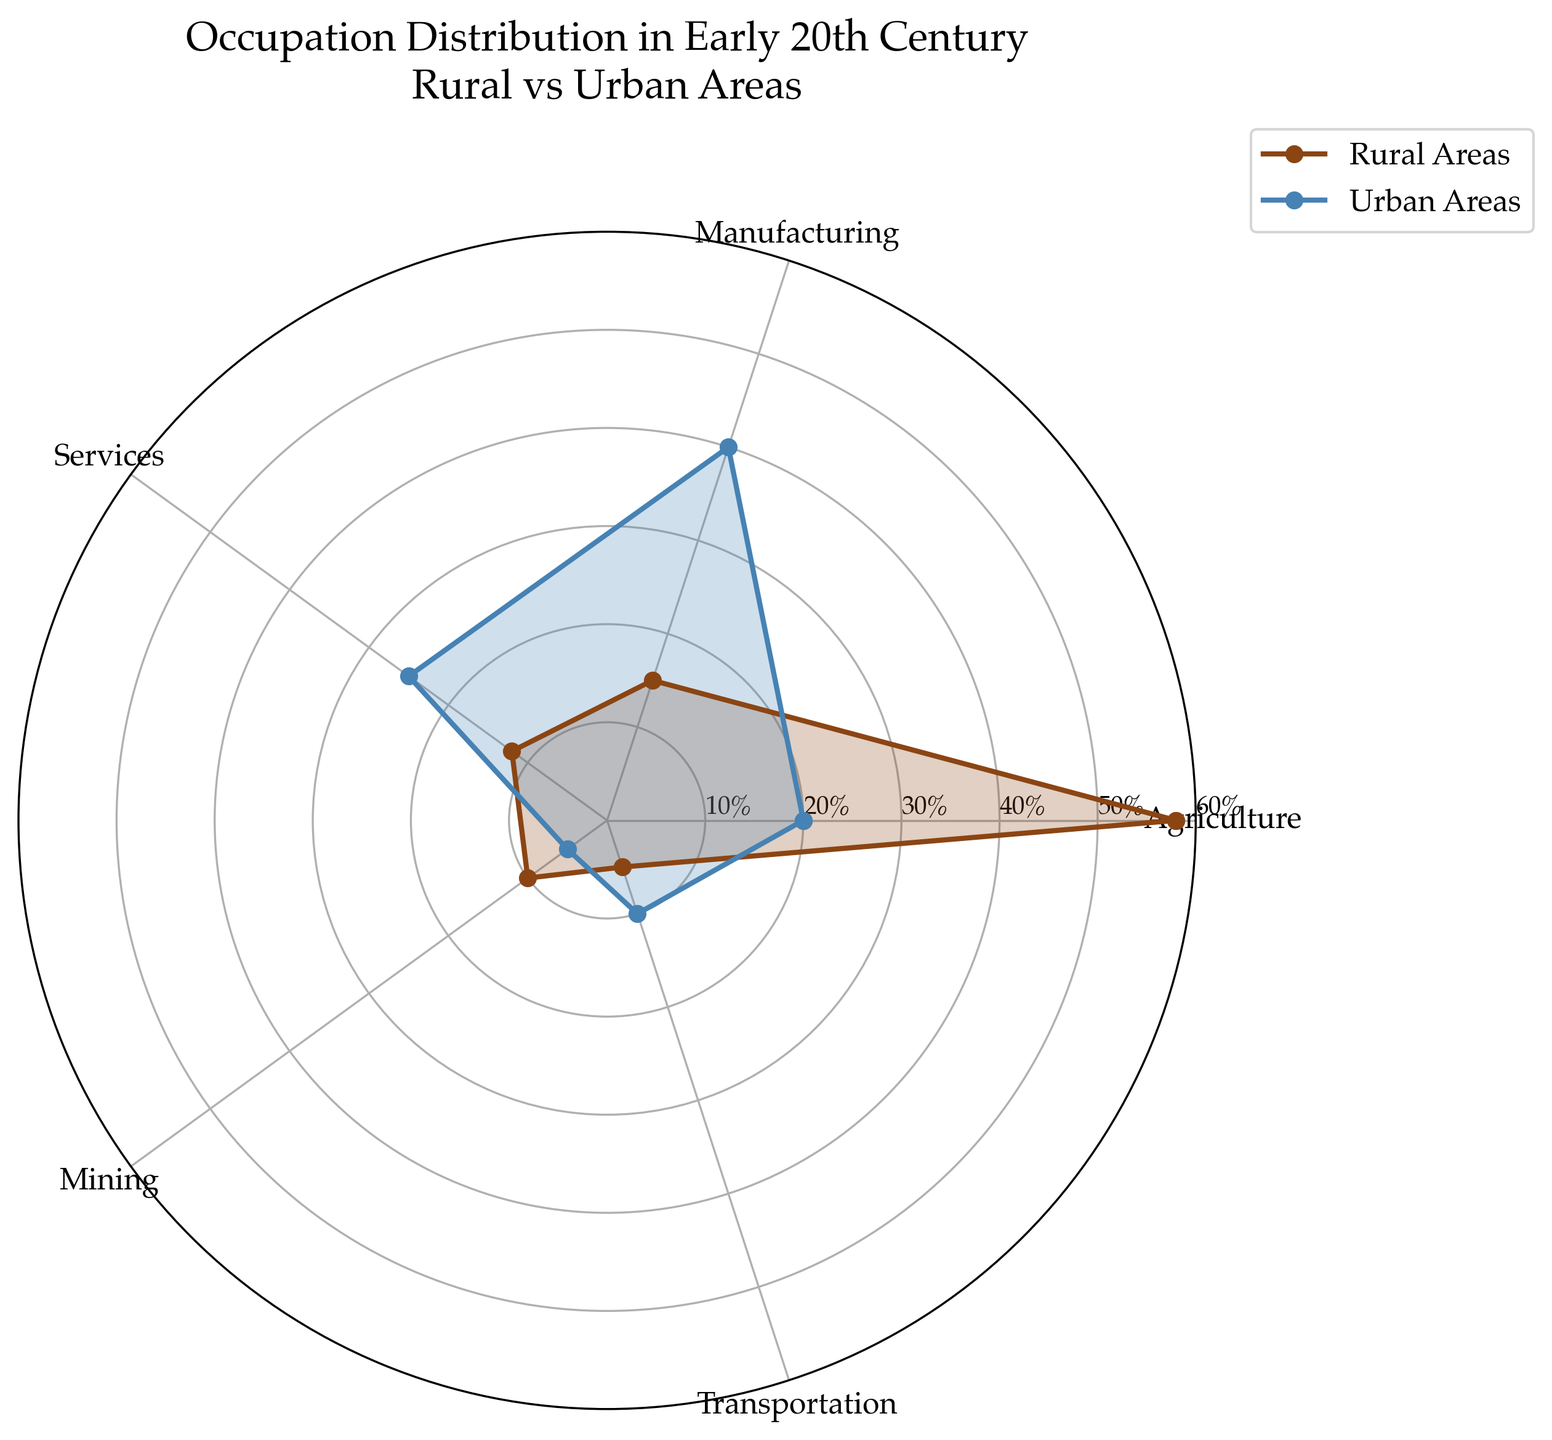What is the percentage of people involved in agriculture in rural areas? The percentage of people involved in agriculture in rural areas can be directly found at the Agriculture point on the rural line (usually brown) in the radar chart.
Answer: 58% Which industry sector has the highest percentage of workers in urban areas? Observe all the sectors on the urban line (usually blue). The sector with the highest value will be the answer. Manufacturing has the highest point on the urban line.
Answer: Manufacturing What is the difference between the percentage of rural and urban workers in services? Find the values for services in rural and urban lines, then subtract the urban value from the rural value. Rural is 12%, and urban is 25%, so 12 - 25 = -13%.
Answer: -13% Which area has a higher percentage of workers in transportation: rural or urban? On the radar chart, compare the rural and urban values at the Transportation point. Rural shows 5%, and urban shows 10%, so urban is higher.
Answer: Urban What is the total percentage of workers in rural areas across all sectors? Sum the rural percentages: 58 (Agriculture) + 15 (Manufacturing) + 12 (Services) + 10 (Mining) + 5 (Transportation) = 100%
Answer: 100% Which sector has a more significant difference between rural and urban employment percentages? Calculate the absolute differences for each sector: Agriculture (58-20=38), Manufacturing (15-40=-25), Services (12-25=-13), Mining (10-5=5), Transportation (5-10=-5). The largest absolute value is for Agriculture with 38%.
Answer: Agriculture In which industry sector are rural and urban employment percentages the closest? Find the differences for each sector: Agriculture (58-20=38), Manufacturing (15-40=25), Services (12-25=13), Mining (10-5=5), Transportation (5-10=5). Mining and Transportation have the smallest difference of 5%.
Answer: Mining and Transportation How does the employment distribution in mining differ between rural and urban areas? Find the mining values on the rural and urban lines: 10% in rural and 5% in urban. There is a higher percentage of mining workers in rural areas compared to urban areas.
Answer: Rural higher by 5% 